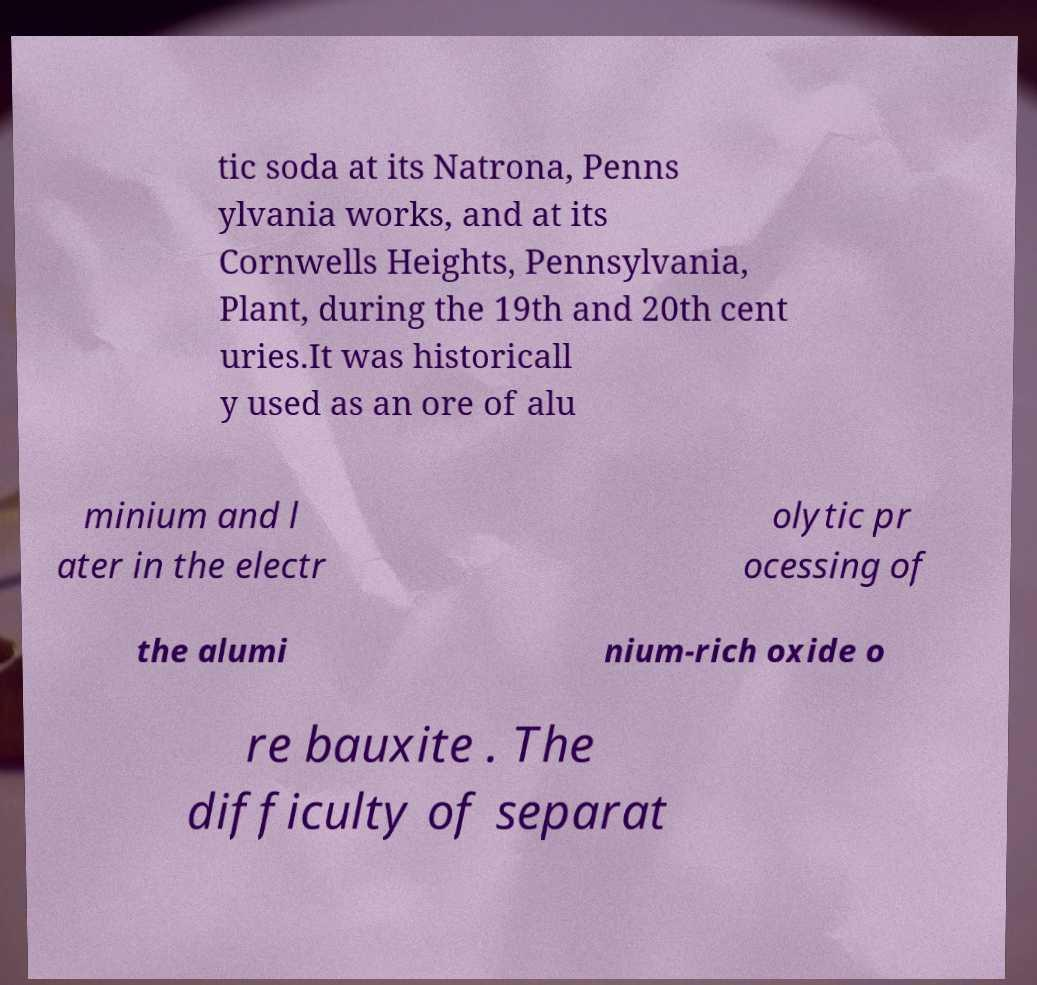Please read and relay the text visible in this image. What does it say? tic soda at its Natrona, Penns ylvania works, and at its Cornwells Heights, Pennsylvania, Plant, during the 19th and 20th cent uries.It was historicall y used as an ore of alu minium and l ater in the electr olytic pr ocessing of the alumi nium-rich oxide o re bauxite . The difficulty of separat 